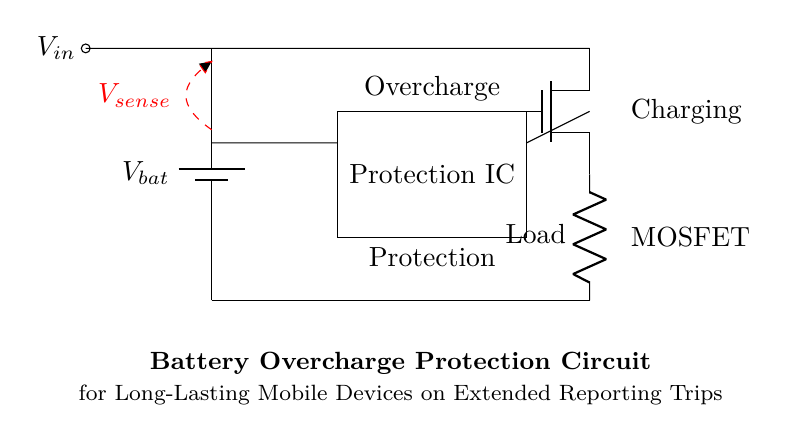What is the role of the Protection IC in this circuit? The Protection IC is responsible for monitoring the battery voltage and preventing overcharging, ensuring safe operation during charging.
Answer: Monitoring and preventing overcharging What type of MOSFET is used in this circuit? The circuit uses an N-channel MOSFET, indicated by the symbol Tnmos, which is typically used for low-side switching.
Answer: N-channel What is the purpose of the voltage sense component? The voltage sense component measures the battery voltage and provides feedback to the Protection IC to control charging.
Answer: Feedback for voltage measurement How many main components are in this circuit? The main components include the battery, Protection IC, MOSFET, and load; totaling four key elements.
Answer: Four What does the dashed red line represent in the circuit diagram? The dashed red line represents the connection for voltage sensing from the battery to the Protection IC, facilitating monitoring of the battery voltage.
Answer: Voltage sensing connection What action does the circuit take when an overcharge is detected? When an overcharge is detected, the Protection IC will turn off the MOSFET, interrupting the charging process to the battery.
Answer: Turns off the MOSFET 